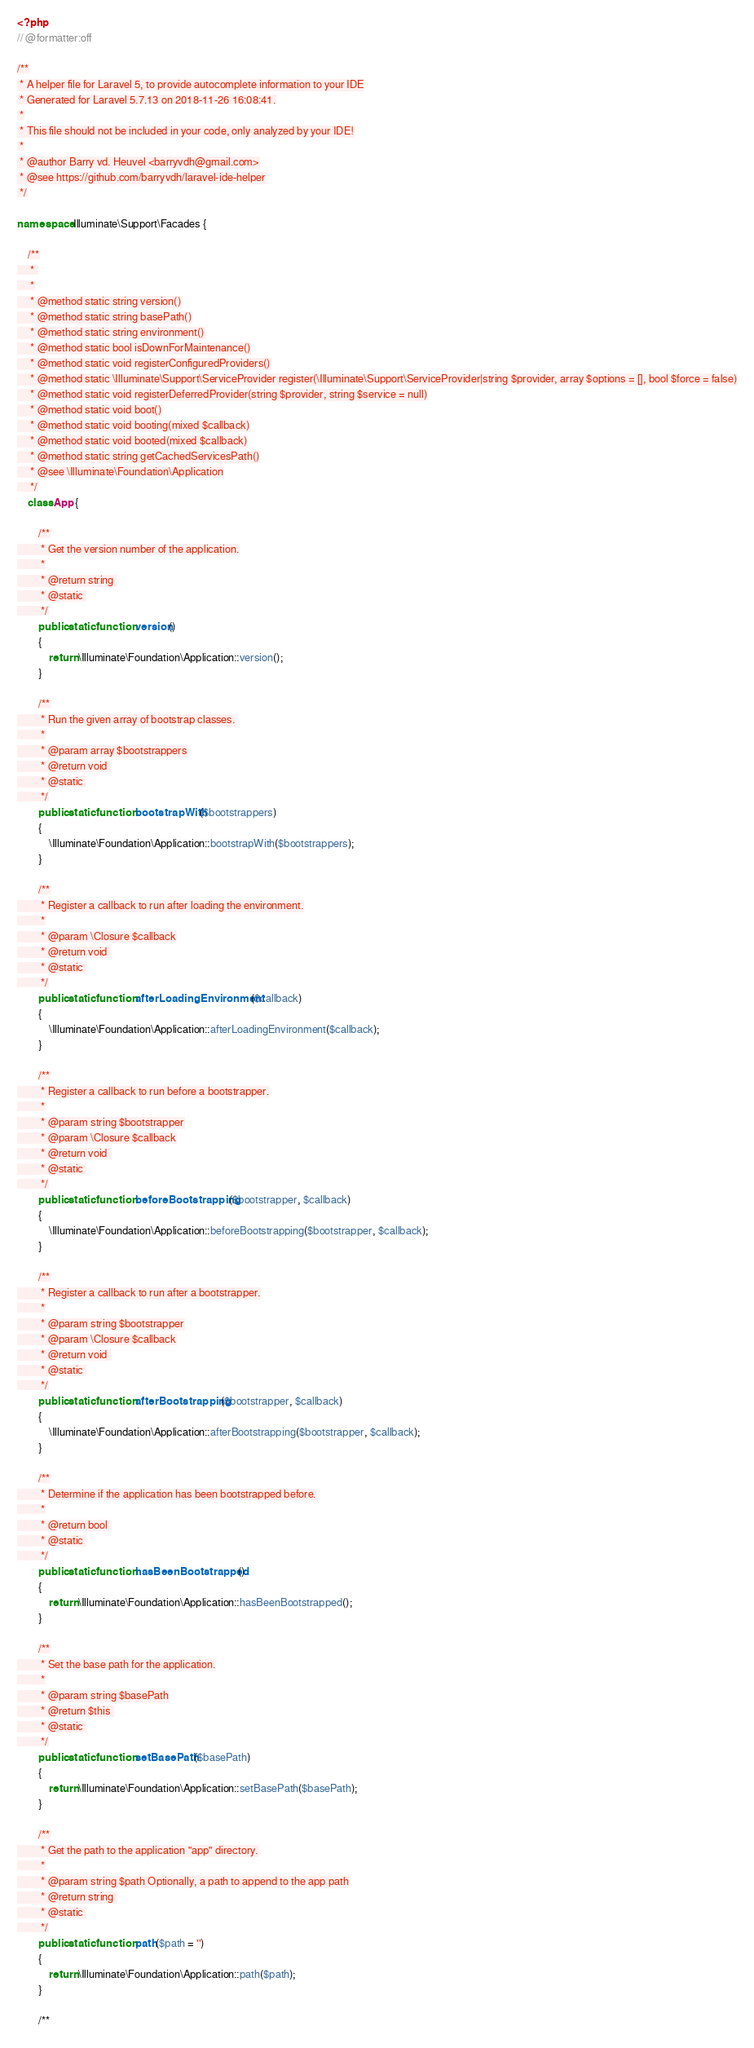<code> <loc_0><loc_0><loc_500><loc_500><_PHP_><?php
// @formatter:off

/**
 * A helper file for Laravel 5, to provide autocomplete information to your IDE
 * Generated for Laravel 5.7.13 on 2018-11-26 16:08:41.
 *
 * This file should not be included in your code, only analyzed by your IDE!
 *
 * @author Barry vd. Heuvel <barryvdh@gmail.com>
 * @see https://github.com/barryvdh/laravel-ide-helper
 */

namespace Illuminate\Support\Facades { 

    /**
     * 
     *
     * @method static string version()
     * @method static string basePath()
     * @method static string environment()
     * @method static bool isDownForMaintenance()
     * @method static void registerConfiguredProviders()
     * @method static \Illuminate\Support\ServiceProvider register(\Illuminate\Support\ServiceProvider|string $provider, array $options = [], bool $force = false)
     * @method static void registerDeferredProvider(string $provider, string $service = null)
     * @method static void boot()
     * @method static void booting(mixed $callback)
     * @method static void booted(mixed $callback)
     * @method static string getCachedServicesPath()
     * @see \Illuminate\Foundation\Application
     */ 
    class App {
        
        /**
         * Get the version number of the application.
         *
         * @return string 
         * @static 
         */ 
        public static function version()
        {
            return \Illuminate\Foundation\Application::version();
        }
        
        /**
         * Run the given array of bootstrap classes.
         *
         * @param array $bootstrappers
         * @return void 
         * @static 
         */ 
        public static function bootstrapWith($bootstrappers)
        {
            \Illuminate\Foundation\Application::bootstrapWith($bootstrappers);
        }
        
        /**
         * Register a callback to run after loading the environment.
         *
         * @param \Closure $callback
         * @return void 
         * @static 
         */ 
        public static function afterLoadingEnvironment($callback)
        {
            \Illuminate\Foundation\Application::afterLoadingEnvironment($callback);
        }
        
        /**
         * Register a callback to run before a bootstrapper.
         *
         * @param string $bootstrapper
         * @param \Closure $callback
         * @return void 
         * @static 
         */ 
        public static function beforeBootstrapping($bootstrapper, $callback)
        {
            \Illuminate\Foundation\Application::beforeBootstrapping($bootstrapper, $callback);
        }
        
        /**
         * Register a callback to run after a bootstrapper.
         *
         * @param string $bootstrapper
         * @param \Closure $callback
         * @return void 
         * @static 
         */ 
        public static function afterBootstrapping($bootstrapper, $callback)
        {
            \Illuminate\Foundation\Application::afterBootstrapping($bootstrapper, $callback);
        }
        
        /**
         * Determine if the application has been bootstrapped before.
         *
         * @return bool 
         * @static 
         */ 
        public static function hasBeenBootstrapped()
        {
            return \Illuminate\Foundation\Application::hasBeenBootstrapped();
        }
        
        /**
         * Set the base path for the application.
         *
         * @param string $basePath
         * @return $this 
         * @static 
         */ 
        public static function setBasePath($basePath)
        {
            return \Illuminate\Foundation\Application::setBasePath($basePath);
        }
        
        /**
         * Get the path to the application "app" directory.
         *
         * @param string $path Optionally, a path to append to the app path
         * @return string 
         * @static 
         */ 
        public static function path($path = '')
        {
            return \Illuminate\Foundation\Application::path($path);
        }
        
        /**</code> 